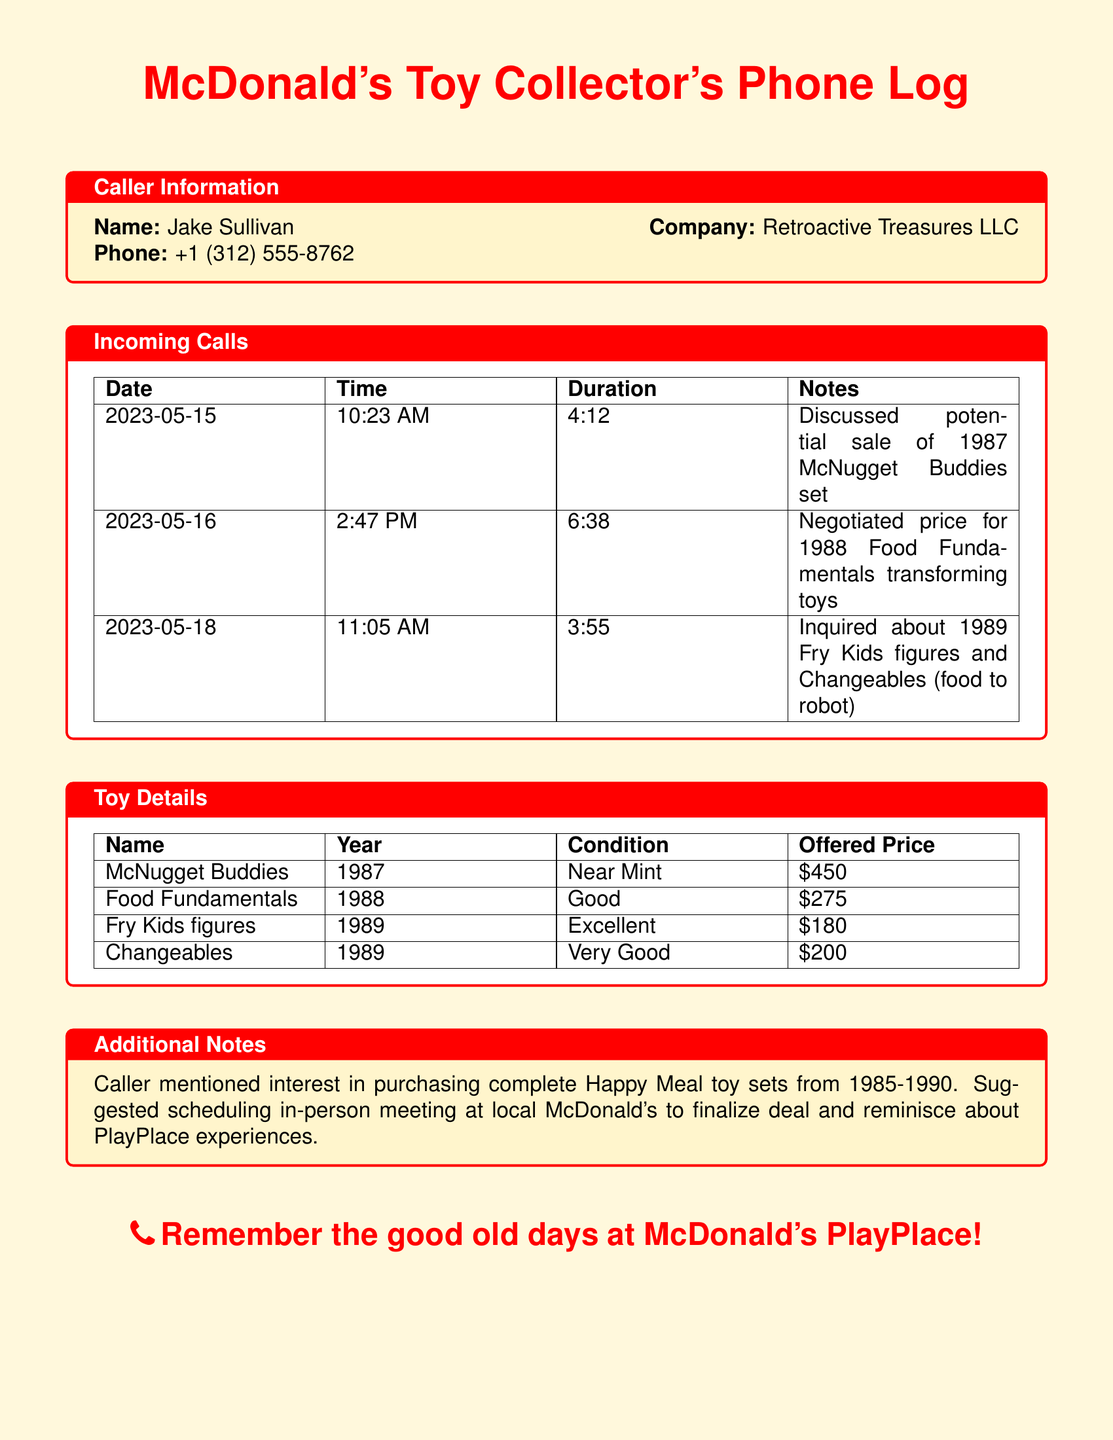what is the name of the caller? The caller's name is listed in the Caller Information section.
Answer: Jake Sullivan what is the company name? The company name is stated under Caller Information.
Answer: Retroactive Treasures LLC when was the first call made? The date of the first incoming call is found in the Incoming Calls section.
Answer: 2023-05-15 how long was the call on May 16? The duration of the call on May 16 is recorded in the Incoming Calls section.
Answer: 6:38 which toy was discussed on May 18? The notes for the call on May 18 indicate which toy was discussed.
Answer: Fry Kids figures what is the offered price for the McNugget Buddies? The offered price is provided in the Toy Details section.
Answer: $450 what year corresponds to the Food Fundamentals toys? The year for the Food Fundamentals toys can be found in the Toy Details section.
Answer: 1988 how many toys are mentioned in the Additional Notes? The Additional Notes mention the types of toys the caller is interested in purchasing.
Answer: Complete Happy Meal toy sets where did the caller suggest to meet? The recommended meeting location is specified in the Additional Notes.
Answer: Local McDonald's what condition are the Changeables in? The condition of the Changeables is detailed in the Toy Details section.
Answer: Very Good 